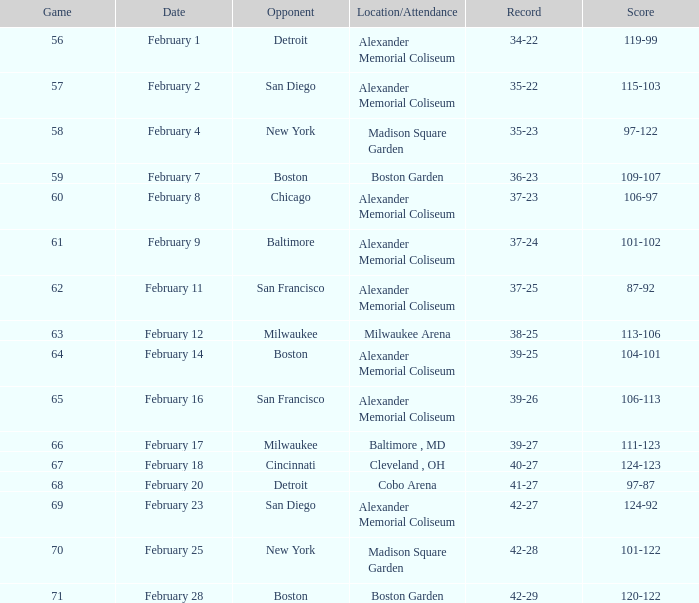What is the Game # that scored 87-92? 62.0. 